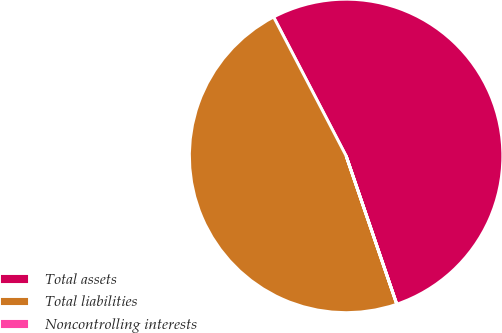Convert chart to OTSL. <chart><loc_0><loc_0><loc_500><loc_500><pie_chart><fcel>Total assets<fcel>Total liabilities<fcel>Noncontrolling interests<nl><fcel>52.42%<fcel>47.58%<fcel>0.01%<nl></chart> 